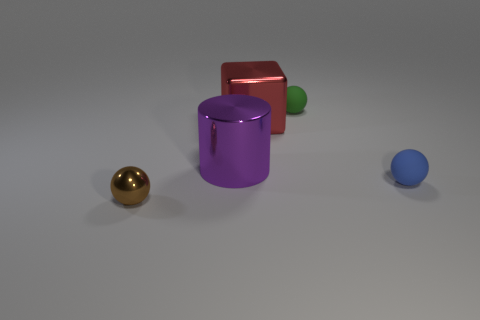The tiny thing right of the small rubber ball behind the matte sphere that is in front of the purple object is what shape? The small object to the right of the small rubber ball, which is positioned behind the matte sphere and in front of the purple cylinder, appears to be a tiny golden sphere. 